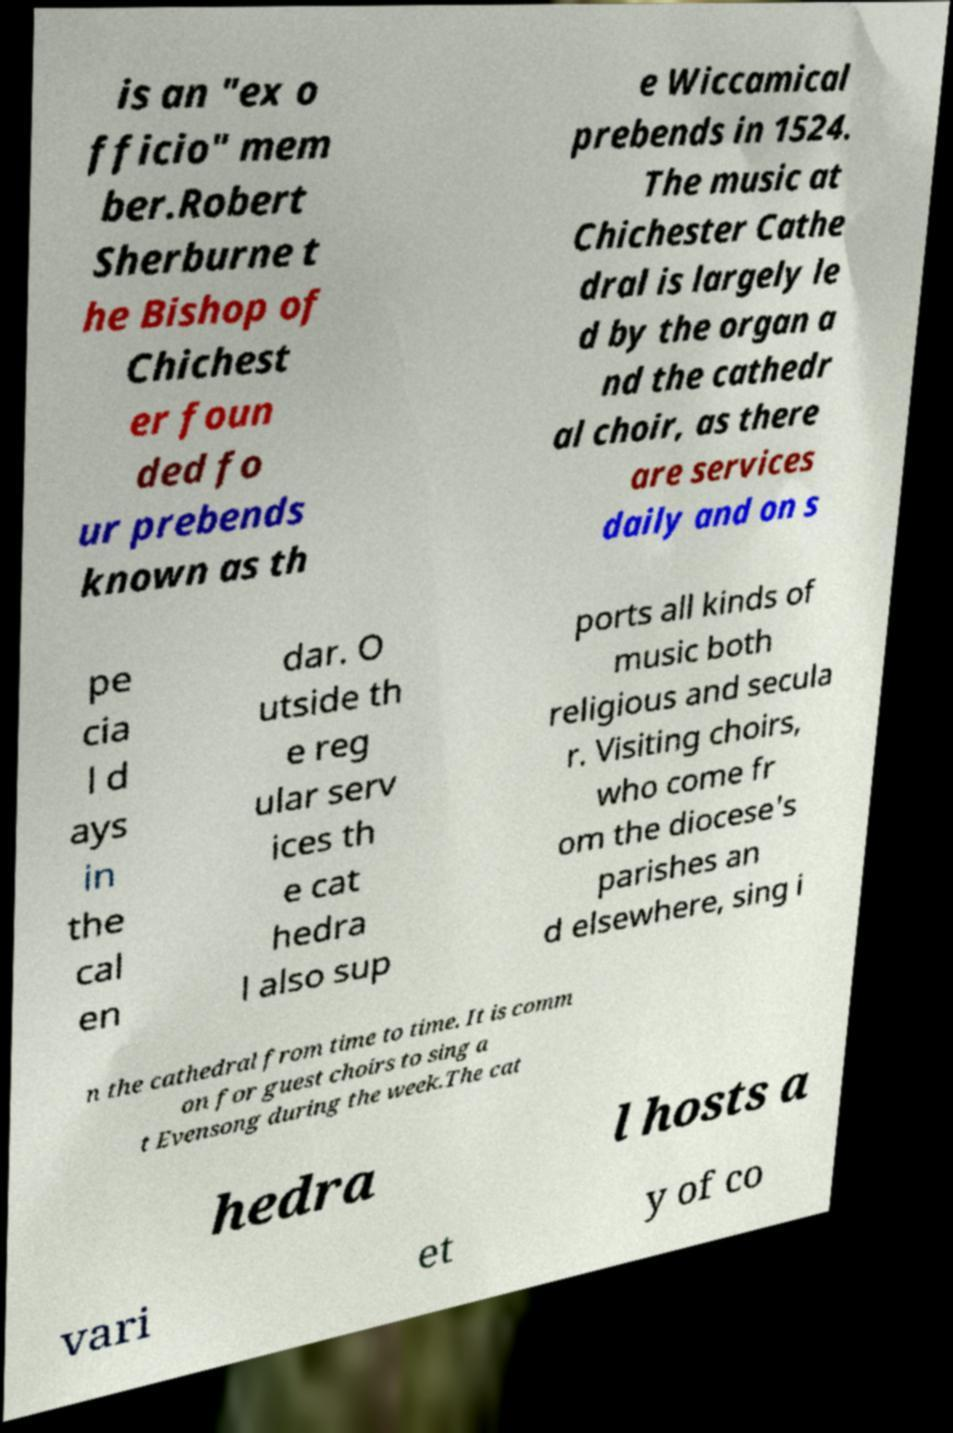For documentation purposes, I need the text within this image transcribed. Could you provide that? is an "ex o fficio" mem ber.Robert Sherburne t he Bishop of Chichest er foun ded fo ur prebends known as th e Wiccamical prebends in 1524. The music at Chichester Cathe dral is largely le d by the organ a nd the cathedr al choir, as there are services daily and on s pe cia l d ays in the cal en dar. O utside th e reg ular serv ices th e cat hedra l also sup ports all kinds of music both religious and secula r. Visiting choirs, who come fr om the diocese's parishes an d elsewhere, sing i n the cathedral from time to time. It is comm on for guest choirs to sing a t Evensong during the week.The cat hedra l hosts a vari et y of co 